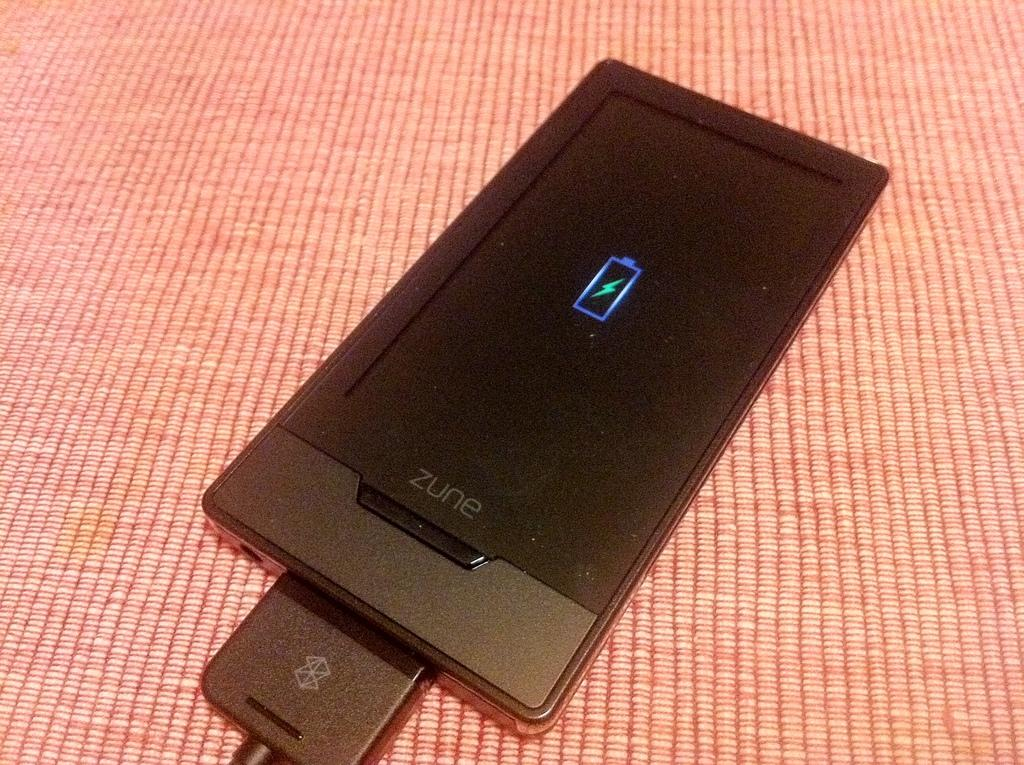Provide a one-sentence caption for the provided image. a phone that had the word zune at the bottom. 